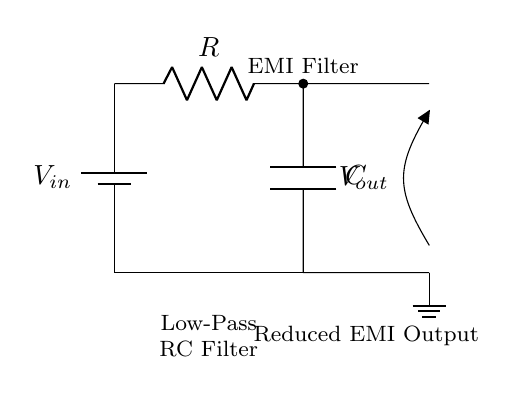What type of filter is represented in this circuit? The circuit shows a low-pass filter, which allows low-frequency signals to pass while attenuating high-frequency signals. This is indicated by the arrangement of the resistor and capacitor in the circuit.
Answer: low-pass filter What is the function of the capacitor in this circuit? The capacitor in this circuit stores electrical energy and, in the context of a low-pass filter, it helps to block high-frequency signals while allowing low-frequency signals to pass through to the output.
Answer: blocks high-frequency signals What component is used to reduce electromagnetic interference? The resistor and capacitor together form the filter circuit that reduces electromagnetic interference (EMI) by filtering out unwanted high-frequency components.
Answer: resistor and capacitor What does the output voltage represent in this circuit? The output voltage represents the voltage across the load that has had unwanted high-frequency noise attenuated by the filter, resulting in a cleaner signal that is less affected by EMI.
Answer: reduced EMI output What is the relationship between resistance and frequency in this RC filter? In a low-pass RC filter, as resistance increases, the cutoff frequency decreases, meaning the filter will allow even less high-frequency components to pass, thus providing better EMI reduction.
Answer: resistance increases, frequency decreases What is the purpose of the ground in this circuit? The ground serves as a common reference point for the circuit, allowing all components to return to the same potential level, which is crucial for the correct operation of the filter and overall circuit stability.
Answer: common reference point 